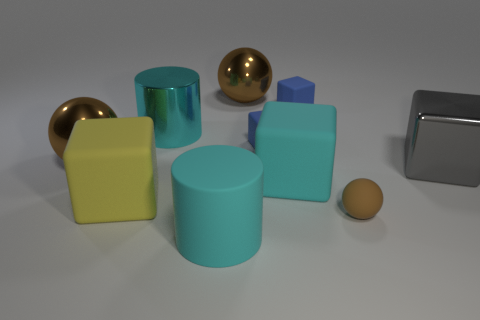Is the tiny brown ball made of the same material as the gray block?
Ensure brevity in your answer.  No. Are there fewer cyan objects that are to the left of the large cyan matte cylinder than objects in front of the yellow matte cube?
Make the answer very short. Yes. There is a brown shiny ball that is on the left side of the cyan cylinder behind the gray thing; how many spheres are right of it?
Your response must be concise. 2. Do the big matte cylinder and the large shiny cylinder have the same color?
Offer a terse response. Yes. Is there a metallic object that has the same color as the rubber cylinder?
Your answer should be very brief. Yes. There is a rubber cylinder that is the same size as the cyan cube; what is its color?
Keep it short and to the point. Cyan. Is there a small purple matte object of the same shape as the yellow rubber thing?
Ensure brevity in your answer.  No. There is a metallic object that is the same color as the large matte cylinder; what is its shape?
Provide a short and direct response. Cylinder. There is a cyan cylinder behind the cylinder that is in front of the big metallic block; are there any tiny blue matte objects that are in front of it?
Your response must be concise. Yes. There is a cyan metallic thing that is the same size as the yellow rubber block; what shape is it?
Offer a very short reply. Cylinder. 